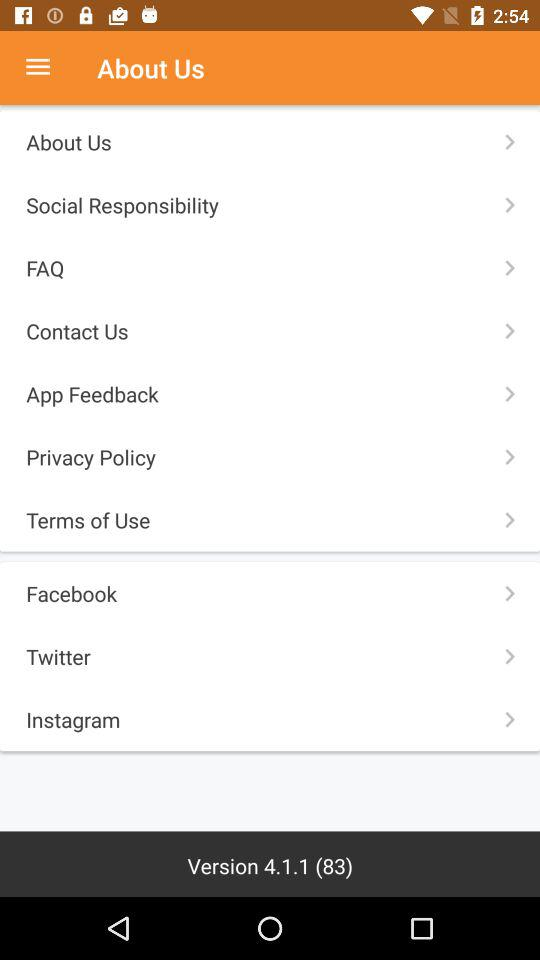What is the version number? The version number is 4.1.1 (83). 